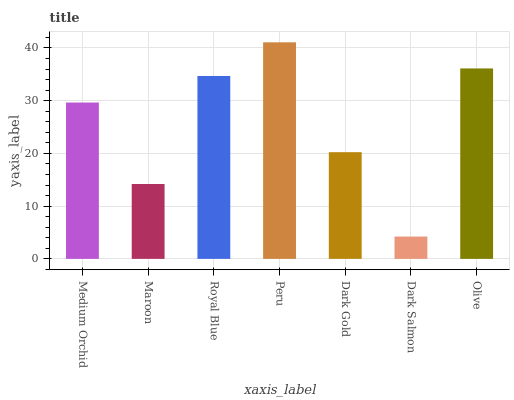Is Maroon the minimum?
Answer yes or no. No. Is Maroon the maximum?
Answer yes or no. No. Is Medium Orchid greater than Maroon?
Answer yes or no. Yes. Is Maroon less than Medium Orchid?
Answer yes or no. Yes. Is Maroon greater than Medium Orchid?
Answer yes or no. No. Is Medium Orchid less than Maroon?
Answer yes or no. No. Is Medium Orchid the high median?
Answer yes or no. Yes. Is Medium Orchid the low median?
Answer yes or no. Yes. Is Olive the high median?
Answer yes or no. No. Is Royal Blue the low median?
Answer yes or no. No. 